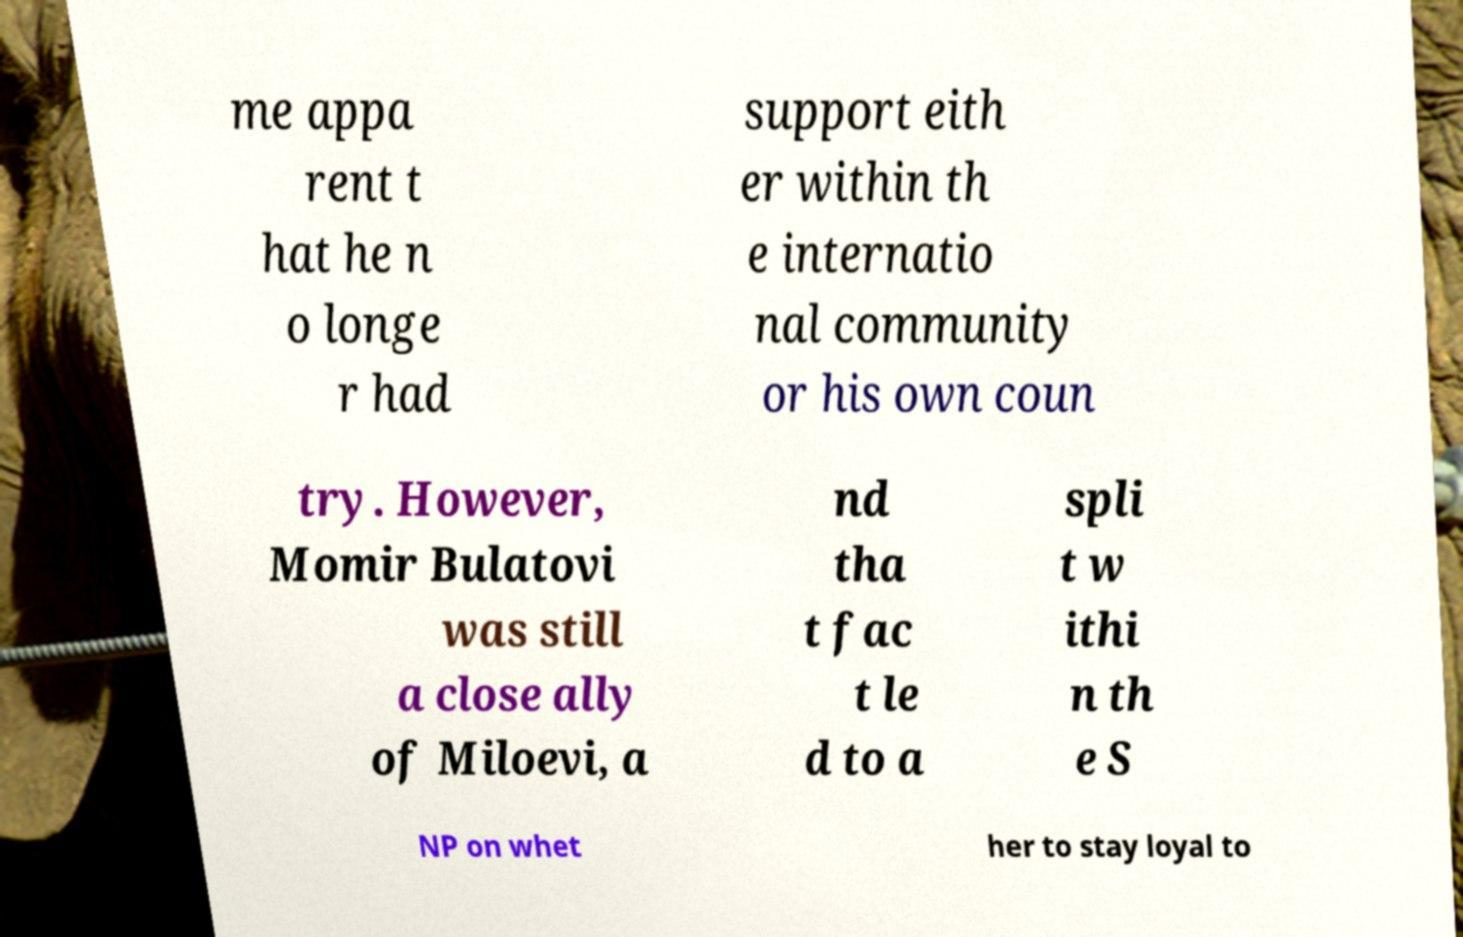For documentation purposes, I need the text within this image transcribed. Could you provide that? me appa rent t hat he n o longe r had support eith er within th e internatio nal community or his own coun try. However, Momir Bulatovi was still a close ally of Miloevi, a nd tha t fac t le d to a spli t w ithi n th e S NP on whet her to stay loyal to 